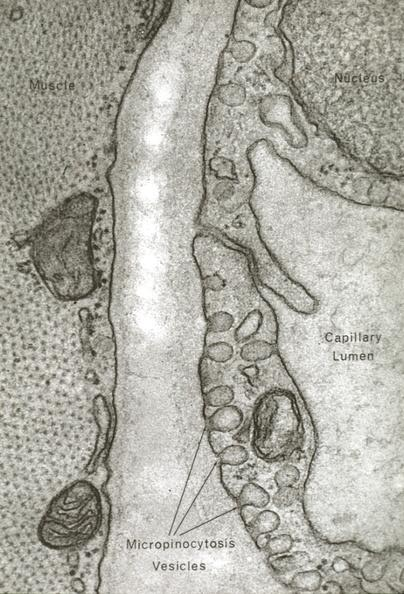what is present?
Answer the question using a single word or phrase. Vasculature 